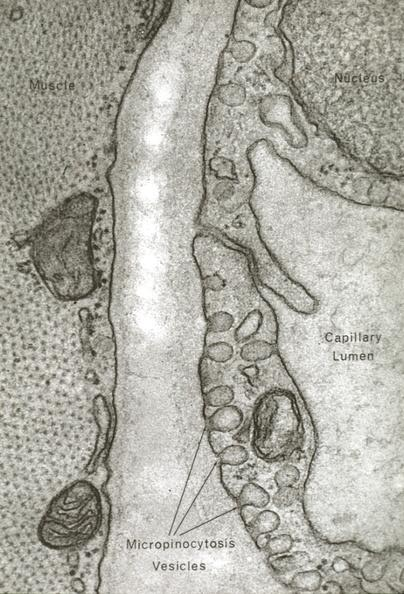what is present?
Answer the question using a single word or phrase. Vasculature 